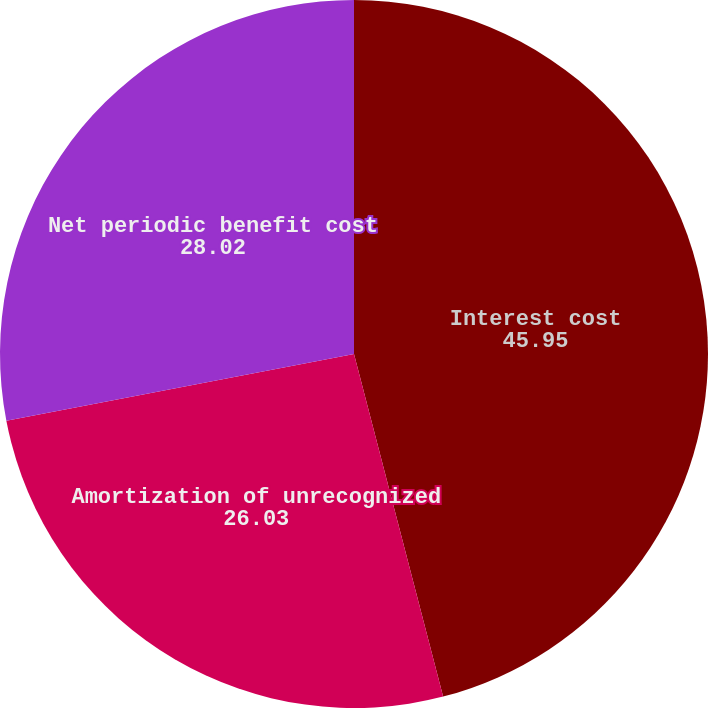Convert chart. <chart><loc_0><loc_0><loc_500><loc_500><pie_chart><fcel>Interest cost<fcel>Amortization of unrecognized<fcel>Net periodic benefit cost<nl><fcel>45.95%<fcel>26.03%<fcel>28.02%<nl></chart> 